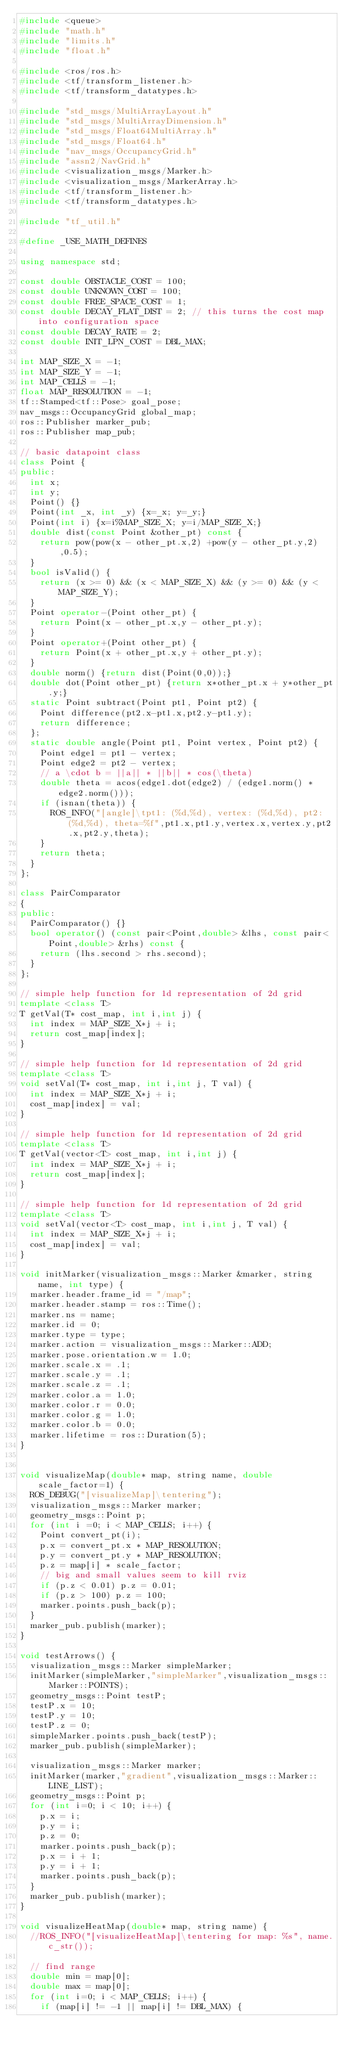<code> <loc_0><loc_0><loc_500><loc_500><_C++_>#include <queue>
#include "math.h"
#include "limits.h"
#include "float.h"

#include <ros/ros.h>
#include <tf/transform_listener.h>
#include <tf/transform_datatypes.h>

#include "std_msgs/MultiArrayLayout.h"
#include "std_msgs/MultiArrayDimension.h"
#include "std_msgs/Float64MultiArray.h"
#include "std_msgs/Float64.h"
#include "nav_msgs/OccupancyGrid.h"
#include "assn2/NavGrid.h"
#include <visualization_msgs/Marker.h>
#include <visualization_msgs/MarkerArray.h>
#include <tf/transform_listener.h>
#include <tf/transform_datatypes.h>

#include "tf_util.h"

#define _USE_MATH_DEFINES

using namespace std;

const double OBSTACLE_COST = 100;
const double UNKNOWN_COST = 100;
const double FREE_SPACE_COST = 1;
const double DECAY_FLAT_DIST = 2; // this turns the cost map into configuration space
const double DECAY_RATE = 2;
const double INIT_LPN_COST = DBL_MAX;

int MAP_SIZE_X = -1;
int MAP_SIZE_Y = -1;
int MAP_CELLS = -1;
float MAP_RESOLUTION = -1;
tf::Stamped<tf::Pose> goal_pose;
nav_msgs::OccupancyGrid global_map;
ros::Publisher marker_pub;
ros::Publisher map_pub;

// basic datapoint class
class Point {
public:
  int x;
  int y;
  Point() {}
  Point(int _x, int _y) {x=_x; y=_y;}
  Point(int i) {x=i%MAP_SIZE_X; y=i/MAP_SIZE_X;}
  double dist(const Point &other_pt) const {
    return pow(pow(x - other_pt.x,2) +pow(y - other_pt.y,2),0.5);
  }
  bool isValid() {
    return (x >= 0) && (x < MAP_SIZE_X) && (y >= 0) && (y < MAP_SIZE_Y);
  }
  Point operator-(Point other_pt) {
    return Point(x - other_pt.x,y - other_pt.y);
  }
  Point operator+(Point other_pt) {
    return Point(x + other_pt.x,y + other_pt.y);
  }
  double norm() {return dist(Point(0,0));}
  double dot(Point other_pt) {return x*other_pt.x + y*other_pt.y;}
  static Point subtract(Point pt1, Point pt2) {
    Point difference(pt2.x-pt1.x,pt2.y-pt1.y);
    return difference;
  };
  static double angle(Point pt1, Point vertex, Point pt2) {
    Point edge1 = pt1 - vertex;
    Point edge2 = pt2 - vertex;
    // a \cdot b = ||a|| * ||b|| * cos(\theta)
    double theta = acos(edge1.dot(edge2) / (edge1.norm() * edge2.norm()));
    if (isnan(theta)) {
      ROS_INFO("[angle]\tpt1: (%d,%d), vertex: (%d,%d), pt2: (%d,%d), theta=%f",pt1.x,pt1.y,vertex.x,vertex.y,pt2.x,pt2.y,theta);
    }
    return theta;
  }
};

class PairComparator
{
public:
  PairComparator() {}
  bool operator() (const pair<Point,double> &lhs, const pair<Point,double> &rhs) const {
    return (lhs.second > rhs.second);
  }
};
  
// simple help function for 1d representation of 2d grid
template <class T>
T getVal(T* cost_map, int i,int j) {
  int index = MAP_SIZE_X*j + i;
  return cost_map[index];
}

// simple help function for 1d representation of 2d grid
template <class T>
void setVal(T* cost_map, int i,int j, T val) {
  int index = MAP_SIZE_X*j + i;
  cost_map[index] = val;
}
  
// simple help function for 1d representation of 2d grid
template <class T>
T getVal(vector<T> cost_map, int i,int j) {
  int index = MAP_SIZE_X*j + i;
  return cost_map[index];
}

// simple help function for 1d representation of 2d grid
template <class T>
void setVal(vector<T> cost_map, int i,int j, T val) {
  int index = MAP_SIZE_X*j + i;
  cost_map[index] = val;
}

void initMarker(visualization_msgs::Marker &marker, string name, int type) {
  marker.header.frame_id = "/map";
  marker.header.stamp = ros::Time();
  marker.ns = name;
  marker.id = 0;
  marker.type = type;
  marker.action = visualization_msgs::Marker::ADD;
  marker.pose.orientation.w = 1.0;
  marker.scale.x = .1;
  marker.scale.y = .1;
  marker.scale.z = .1;
  marker.color.a = 1.0;
  marker.color.r = 0.0;
  marker.color.g = 1.0;
  marker.color.b = 0.0;
  marker.lifetime = ros::Duration(5);
}


void visualizeMap(double* map, string name, double scale_factor=1) {
  ROS_DEBUG("[visualizeMap]\tentering");
  visualization_msgs::Marker marker;
  geometry_msgs::Point p;
  for (int i =0; i < MAP_CELLS; i++) {
    Point convert_pt(i);
    p.x = convert_pt.x * MAP_RESOLUTION;
    p.y = convert_pt.y * MAP_RESOLUTION;
    p.z = map[i] * scale_factor;
    // big and small values seem to kill rviz
    if (p.z < 0.01) p.z = 0.01;
    if (p.z > 100) p.z = 100;
    marker.points.push_back(p);
  }
  marker_pub.publish(marker);
}

void testArrows() {
  visualization_msgs::Marker simpleMarker;
  initMarker(simpleMarker,"simpleMarker",visualization_msgs::Marker::POINTS);
  geometry_msgs::Point testP;
  testP.x = 10;
  testP.y = 10;
  testP.z = 0;
  simpleMarker.points.push_back(testP);
  marker_pub.publish(simpleMarker);

  visualization_msgs::Marker marker;
  initMarker(marker,"gradient",visualization_msgs::Marker::LINE_LIST);
  geometry_msgs::Point p;
  for (int i=0; i < 10; i++) {
    p.x = i;
    p.y = i;
    p.z = 0;
    marker.points.push_back(p);
    p.x = i + 1;
    p.y = i + 1;
    marker.points.push_back(p);
  }
  marker_pub.publish(marker);
}

void visualizeHeatMap(double* map, string name) {
  //ROS_INFO("[visualizeHeatMap]\tentering for map: %s", name.c_str());

  // find range
  double min = map[0];
  double max = map[0];
  for (int i=0; i < MAP_CELLS; i++) {
    if (map[i] != -1 || map[i] != DBL_MAX) {</code> 